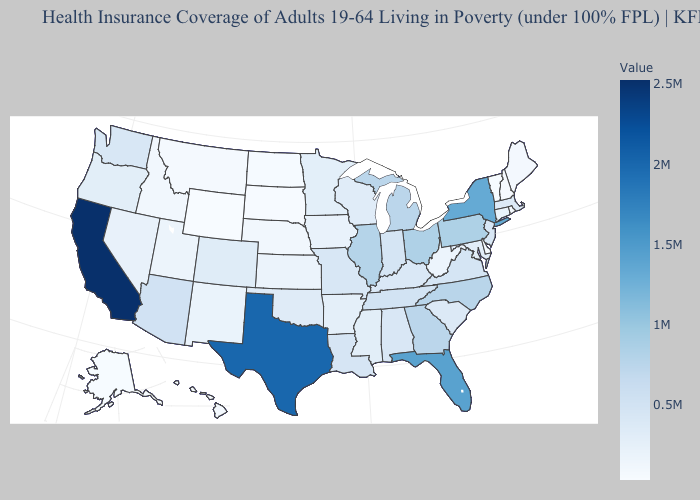Which states hav the highest value in the Northeast?
Quick response, please. New York. Which states have the lowest value in the USA?
Keep it brief. Wyoming. Does Delaware have the lowest value in the South?
Quick response, please. Yes. Among the states that border Iowa , which have the highest value?
Keep it brief. Illinois. Among the states that border Utah , which have the lowest value?
Answer briefly. Wyoming. Which states hav the highest value in the West?
Concise answer only. California. Does Colorado have a higher value than Michigan?
Answer briefly. No. Is the legend a continuous bar?
Keep it brief. Yes. Which states have the highest value in the USA?
Concise answer only. California. 